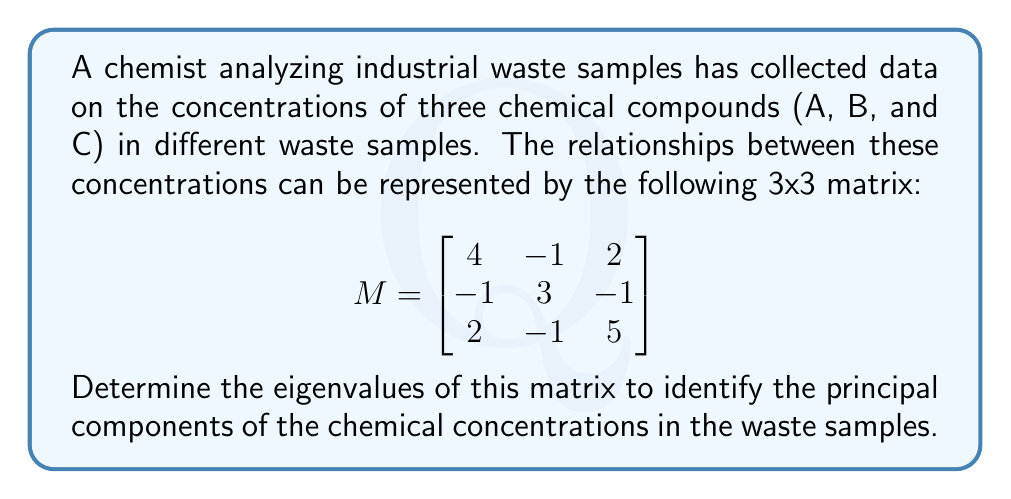Can you solve this math problem? To find the eigenvalues of matrix M, we need to solve the characteristic equation:

1) First, we set up the equation $det(M - \lambda I) = 0$, where $\lambda$ represents the eigenvalues and I is the 3x3 identity matrix:

   $$det\begin{pmatrix}
   4-\lambda & -1 & 2 \\
   -1 & 3-\lambda & -1 \\
   2 & -1 & 5-\lambda
   \end{pmatrix} = 0$$

2) Expand the determinant:
   $$(4-\lambda)(3-\lambda)(5-\lambda) + (-1)(-1)(2) + (2)(-1)(-1) - (2)(3-\lambda)(2) - (4-\lambda)(-1)(-1) - (-1)(-1)(5-\lambda) = 0$$

3) Simplify:
   $$(4-\lambda)(3-\lambda)(5-\lambda) + 2 + 2 - 6(3-\lambda) - (4-\lambda) - (5-\lambda) = 0$$
   
   $$60 - 32\lambda + 5\lambda^2 - \lambda^3 + 4 - 18 + 6\lambda - 4 + \lambda - 5 + \lambda = 0$$

4) Collect terms:
   $$-\lambda^3 + 5\lambda^2 - 24\lambda + 37 = 0$$

5) This is a cubic equation. We can factor out $(\lambda - 1)$:
   $$(\lambda - 1)(-\lambda^2 + 4\lambda - 37) = 0$$

6) Using the quadratic formula on $-\lambda^2 + 4\lambda - 37 = 0$, we get:
   $$\lambda = \frac{4 \pm \sqrt{16 + 148}}{2} = \frac{4 \pm \sqrt{164}}{2} = \frac{4 \pm 2\sqrt{41}}{2}$$

Therefore, the eigenvalues are:
- $\lambda_1 = 1$
- $\lambda_2 = 2 + \sqrt{41}$
- $\lambda_3 = 2 - \sqrt{41}$
Answer: $\lambda_1 = 1$, $\lambda_2 = 2 + \sqrt{41}$, $\lambda_3 = 2 - \sqrt{41}$ 